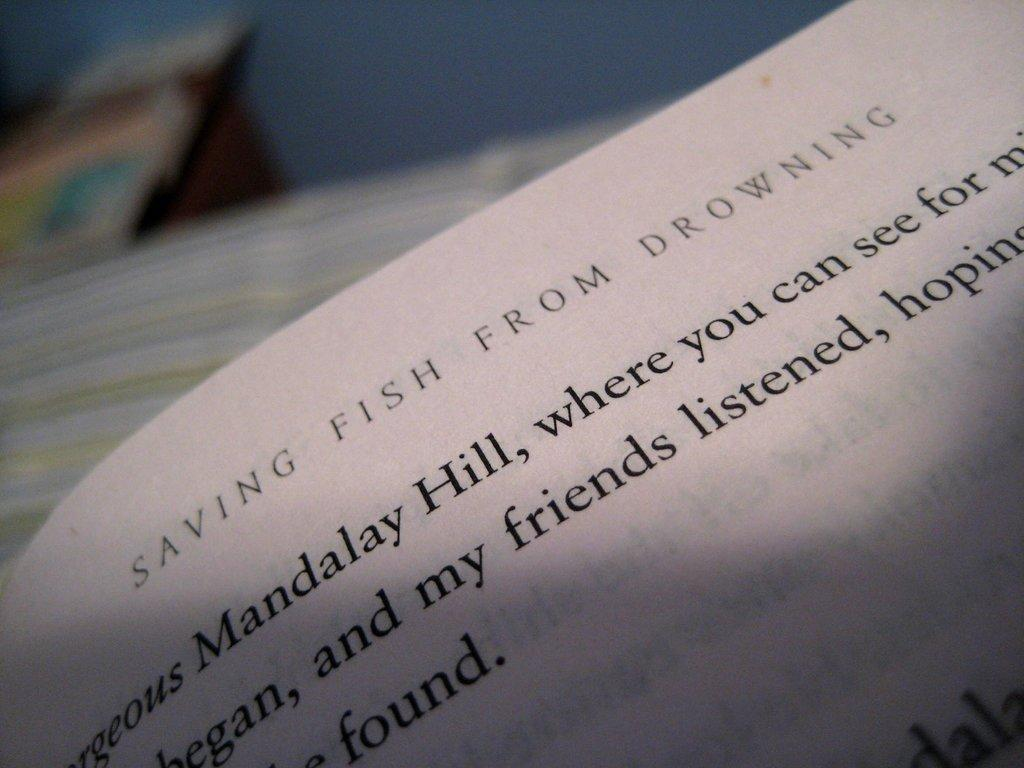<image>
Create a compact narrative representing the image presented. A page of text titled Saving Fish from Drowning. 